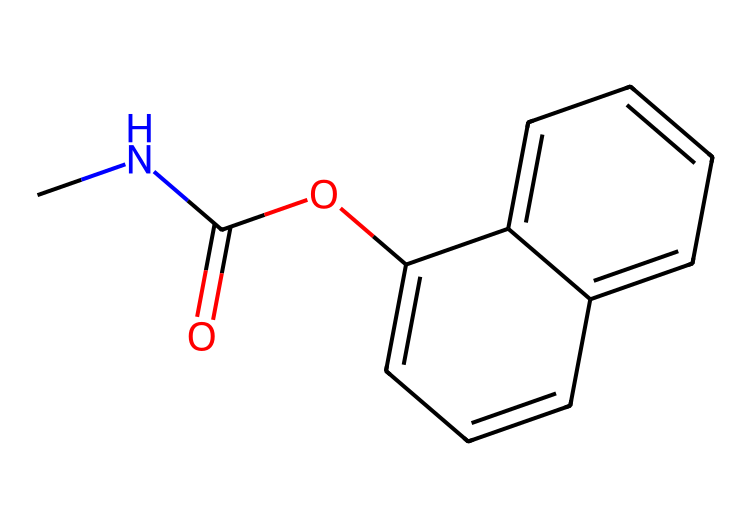What is the name of this chemical? The chemical structure represented by the provided SMILES corresponds to carbaryl, a widely used pesticide.
Answer: carbaryl How many carbon atoms are in the structure? By analyzing the SMILES, we see there are 12 carbon atoms indicated in the arrangement. Each "C" represents a carbon atom.
Answer: 12 What functional group is present in carbaryl? The presence of the "C(=O)" part indicates a carbonyl group (specifically, a carbonyl attached to an oxygen). This functional group is typical of esters or amides, but here it shows it's part of an ester.
Answer: carbonyl group How many rings are present in the structure? The visual representation shows that the structure has two interconnected ring systems, which can be identified from the notation of "c" in the SMILES suggesting aromatic rings.
Answer: 2 What is the main purpose of carbaryl? Carbaryl is primarily used as a pesticide for agricultural and gardening purposes, indicating its role in pest control.
Answer: pest control Which element in the structure denotes potential toxicity? The nitrogen atom (N) in the structure can be associated with various toxic properties typical of many pesticides, including carbaryl.
Answer: nitrogen What type of chemical bonding is most prominent in carbaryl? The chemical structure indicates a high degree of covalent bonding, as seen from the connected carbon atoms and functional groups. Most bonds represent shared electrons typical in organic compounds.
Answer: covalent bonding 